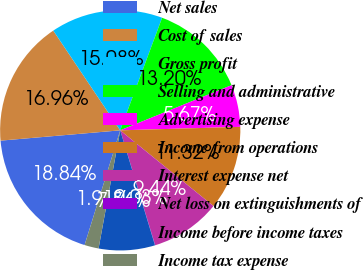<chart> <loc_0><loc_0><loc_500><loc_500><pie_chart><fcel>Net sales<fcel>Cost of sales<fcel>Gross profit<fcel>Selling and administrative<fcel>Advertising expense<fcel>Income from operations<fcel>Interest expense net<fcel>Net loss on extinguishments of<fcel>Income before income taxes<fcel>Income tax expense<nl><fcel>18.84%<fcel>16.96%<fcel>15.08%<fcel>13.2%<fcel>5.67%<fcel>11.32%<fcel>9.44%<fcel>0.03%<fcel>7.56%<fcel>1.91%<nl></chart> 